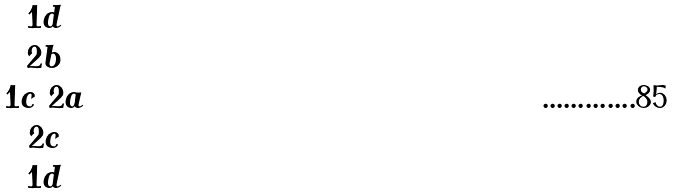Convert formula to latex. <formula><loc_0><loc_0><loc_500><loc_500>\begin{matrix} 1 d \\ 2 b \\ 1 c \ 2 a \\ 2 c \\ 1 d \end{matrix}</formula> 